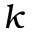<formula> <loc_0><loc_0><loc_500><loc_500>k</formula> 